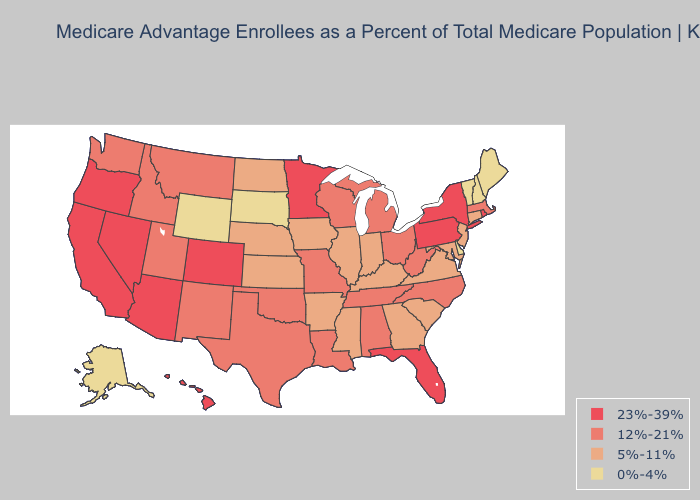What is the lowest value in the South?
Be succinct. 0%-4%. Which states have the highest value in the USA?
Concise answer only. Arizona, California, Colorado, Florida, Hawaii, Minnesota, Nevada, New York, Oregon, Pennsylvania, Rhode Island. What is the lowest value in the Northeast?
Quick response, please. 0%-4%. Which states have the highest value in the USA?
Write a very short answer. Arizona, California, Colorado, Florida, Hawaii, Minnesota, Nevada, New York, Oregon, Pennsylvania, Rhode Island. Which states have the lowest value in the USA?
Concise answer only. Alaska, Delaware, Maine, New Hampshire, South Dakota, Vermont, Wyoming. Among the states that border South Carolina , does North Carolina have the lowest value?
Give a very brief answer. No. Is the legend a continuous bar?
Quick response, please. No. Among the states that border Virginia , does Tennessee have the lowest value?
Be succinct. No. Among the states that border Colorado , does Utah have the lowest value?
Quick response, please. No. Which states have the highest value in the USA?
Answer briefly. Arizona, California, Colorado, Florida, Hawaii, Minnesota, Nevada, New York, Oregon, Pennsylvania, Rhode Island. What is the lowest value in states that border North Dakota?
Keep it brief. 0%-4%. Does the map have missing data?
Give a very brief answer. No. Name the states that have a value in the range 23%-39%?
Write a very short answer. Arizona, California, Colorado, Florida, Hawaii, Minnesota, Nevada, New York, Oregon, Pennsylvania, Rhode Island. What is the lowest value in states that border Nevada?
Give a very brief answer. 12%-21%. 